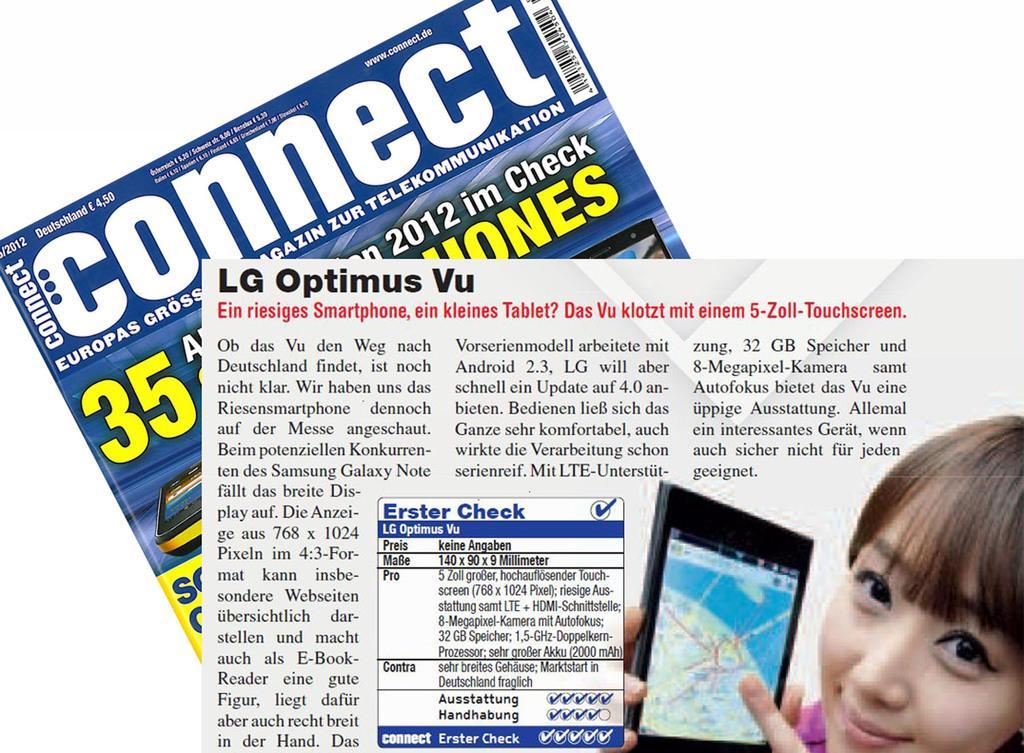In one or two sentences, can you explain what this image depicts? In the image we can see there are posters and there is a picture of a woman holding mobile phone in her hand. On the poster it's written ¨Connect¨. There is matter written on the poster. 